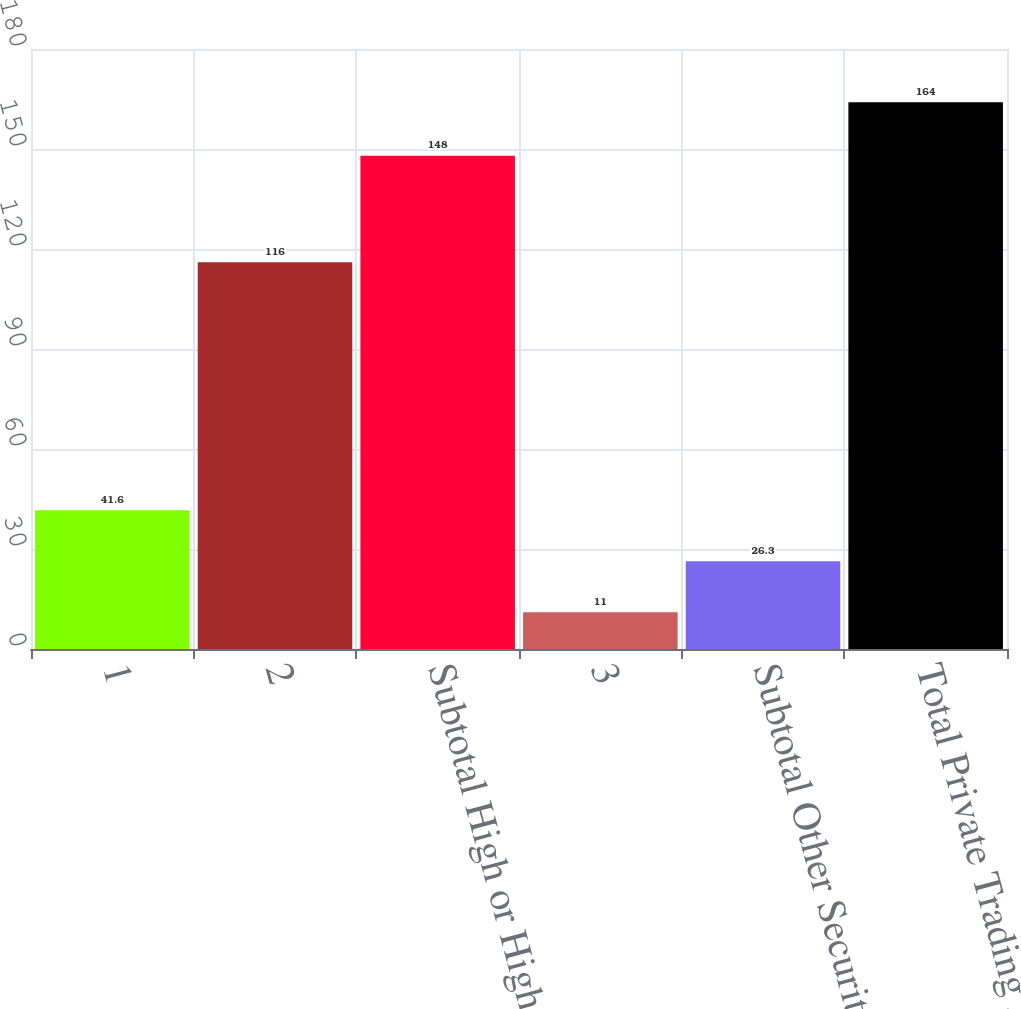Convert chart. <chart><loc_0><loc_0><loc_500><loc_500><bar_chart><fcel>1<fcel>2<fcel>Subtotal High or Highest<fcel>3<fcel>Subtotal Other Securities<fcel>Total Private Trading Account<nl><fcel>41.6<fcel>116<fcel>148<fcel>11<fcel>26.3<fcel>164<nl></chart> 